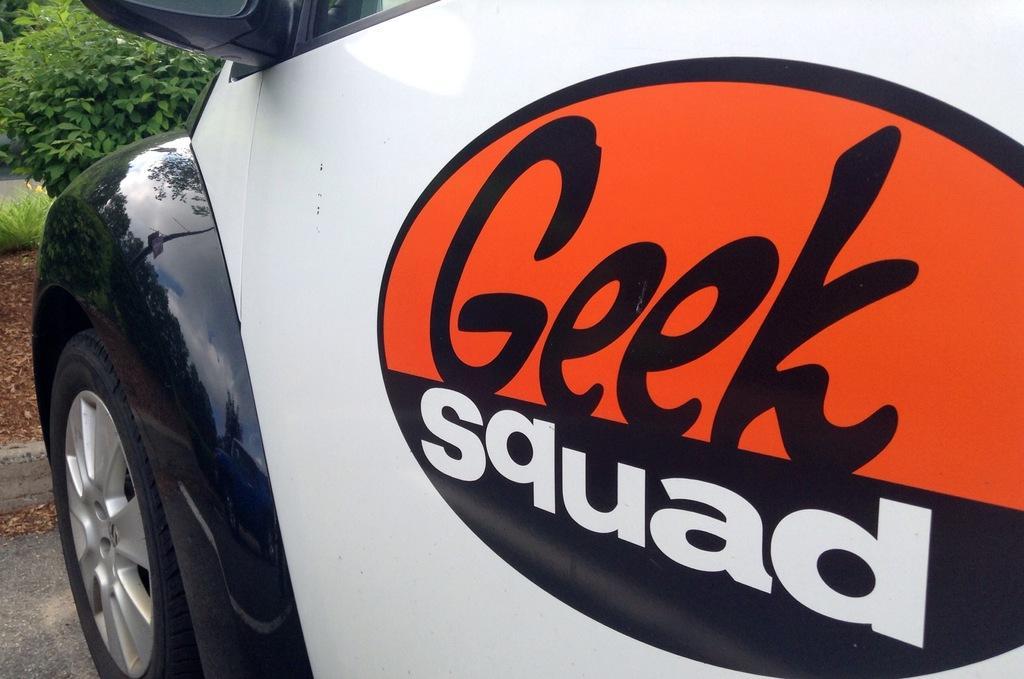In one or two sentences, can you explain what this image depicts? This image consists of a vehicle. This is clicked outside. There is plant in the top left corner. 